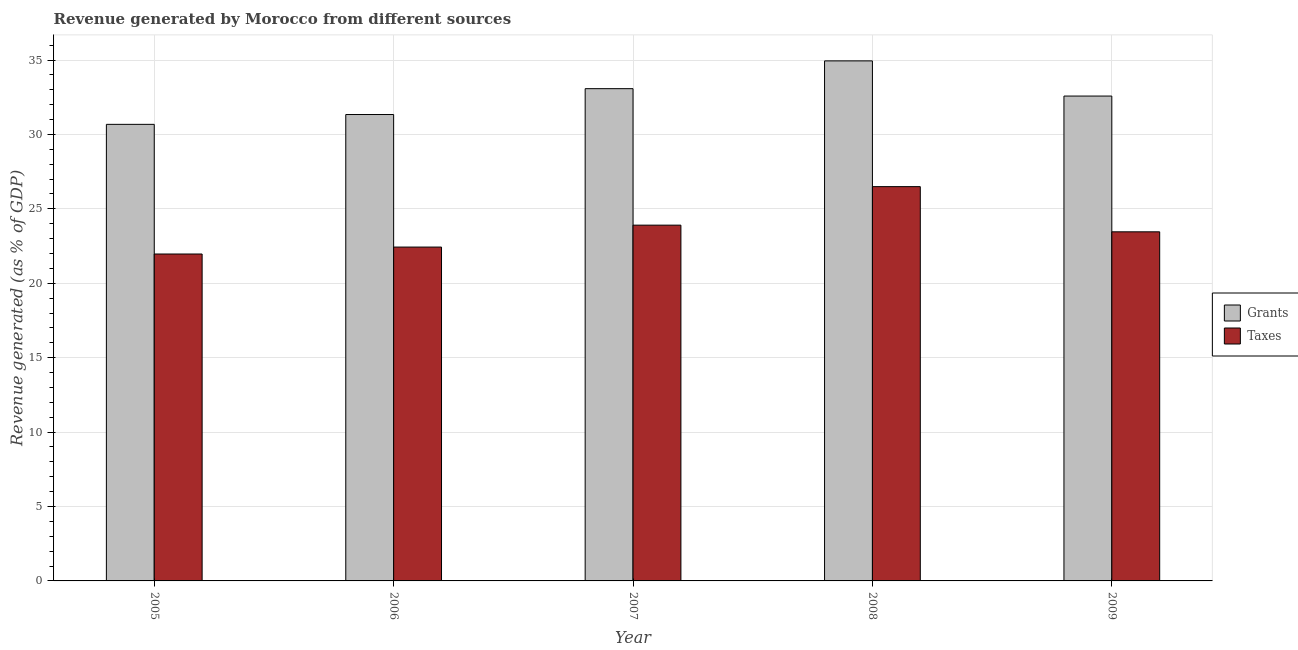How many groups of bars are there?
Keep it short and to the point. 5. Are the number of bars per tick equal to the number of legend labels?
Offer a very short reply. Yes. Are the number of bars on each tick of the X-axis equal?
Provide a succinct answer. Yes. What is the label of the 1st group of bars from the left?
Your answer should be very brief. 2005. In how many cases, is the number of bars for a given year not equal to the number of legend labels?
Offer a terse response. 0. What is the revenue generated by grants in 2006?
Keep it short and to the point. 31.34. Across all years, what is the maximum revenue generated by taxes?
Give a very brief answer. 26.49. Across all years, what is the minimum revenue generated by taxes?
Provide a short and direct response. 21.97. In which year was the revenue generated by grants minimum?
Offer a terse response. 2005. What is the total revenue generated by grants in the graph?
Ensure brevity in your answer.  162.61. What is the difference between the revenue generated by taxes in 2007 and that in 2009?
Your answer should be compact. 0.45. What is the difference between the revenue generated by grants in 2006 and the revenue generated by taxes in 2008?
Offer a very short reply. -3.6. What is the average revenue generated by grants per year?
Ensure brevity in your answer.  32.52. What is the ratio of the revenue generated by grants in 2007 to that in 2008?
Your response must be concise. 0.95. Is the revenue generated by taxes in 2007 less than that in 2009?
Keep it short and to the point. No. Is the difference between the revenue generated by taxes in 2005 and 2009 greater than the difference between the revenue generated by grants in 2005 and 2009?
Keep it short and to the point. No. What is the difference between the highest and the second highest revenue generated by taxes?
Your response must be concise. 2.59. What is the difference between the highest and the lowest revenue generated by taxes?
Ensure brevity in your answer.  4.53. What does the 2nd bar from the left in 2005 represents?
Provide a succinct answer. Taxes. What does the 1st bar from the right in 2007 represents?
Your answer should be compact. Taxes. How many bars are there?
Your answer should be very brief. 10. How many years are there in the graph?
Your answer should be very brief. 5. Are the values on the major ticks of Y-axis written in scientific E-notation?
Offer a very short reply. No. Does the graph contain any zero values?
Your response must be concise. No. Where does the legend appear in the graph?
Ensure brevity in your answer.  Center right. How many legend labels are there?
Give a very brief answer. 2. How are the legend labels stacked?
Your answer should be very brief. Vertical. What is the title of the graph?
Keep it short and to the point. Revenue generated by Morocco from different sources. What is the label or title of the Y-axis?
Offer a terse response. Revenue generated (as % of GDP). What is the Revenue generated (as % of GDP) of Grants in 2005?
Your answer should be very brief. 30.68. What is the Revenue generated (as % of GDP) in Taxes in 2005?
Your response must be concise. 21.97. What is the Revenue generated (as % of GDP) of Grants in 2006?
Your answer should be very brief. 31.34. What is the Revenue generated (as % of GDP) in Taxes in 2006?
Offer a terse response. 22.43. What is the Revenue generated (as % of GDP) in Grants in 2007?
Provide a short and direct response. 33.08. What is the Revenue generated (as % of GDP) of Taxes in 2007?
Offer a very short reply. 23.91. What is the Revenue generated (as % of GDP) of Grants in 2008?
Provide a short and direct response. 34.94. What is the Revenue generated (as % of GDP) of Taxes in 2008?
Your answer should be compact. 26.49. What is the Revenue generated (as % of GDP) in Grants in 2009?
Provide a succinct answer. 32.58. What is the Revenue generated (as % of GDP) in Taxes in 2009?
Your response must be concise. 23.46. Across all years, what is the maximum Revenue generated (as % of GDP) in Grants?
Offer a terse response. 34.94. Across all years, what is the maximum Revenue generated (as % of GDP) in Taxes?
Make the answer very short. 26.49. Across all years, what is the minimum Revenue generated (as % of GDP) of Grants?
Make the answer very short. 30.68. Across all years, what is the minimum Revenue generated (as % of GDP) of Taxes?
Offer a very short reply. 21.97. What is the total Revenue generated (as % of GDP) in Grants in the graph?
Ensure brevity in your answer.  162.61. What is the total Revenue generated (as % of GDP) of Taxes in the graph?
Your response must be concise. 118.25. What is the difference between the Revenue generated (as % of GDP) of Grants in 2005 and that in 2006?
Your response must be concise. -0.66. What is the difference between the Revenue generated (as % of GDP) in Taxes in 2005 and that in 2006?
Your response must be concise. -0.47. What is the difference between the Revenue generated (as % of GDP) in Grants in 2005 and that in 2007?
Provide a succinct answer. -2.4. What is the difference between the Revenue generated (as % of GDP) in Taxes in 2005 and that in 2007?
Keep it short and to the point. -1.94. What is the difference between the Revenue generated (as % of GDP) of Grants in 2005 and that in 2008?
Offer a very short reply. -4.26. What is the difference between the Revenue generated (as % of GDP) of Taxes in 2005 and that in 2008?
Your answer should be very brief. -4.53. What is the difference between the Revenue generated (as % of GDP) in Grants in 2005 and that in 2009?
Your response must be concise. -1.9. What is the difference between the Revenue generated (as % of GDP) of Taxes in 2005 and that in 2009?
Your answer should be compact. -1.49. What is the difference between the Revenue generated (as % of GDP) of Grants in 2006 and that in 2007?
Your answer should be very brief. -1.74. What is the difference between the Revenue generated (as % of GDP) in Taxes in 2006 and that in 2007?
Provide a succinct answer. -1.47. What is the difference between the Revenue generated (as % of GDP) of Grants in 2006 and that in 2008?
Make the answer very short. -3.6. What is the difference between the Revenue generated (as % of GDP) in Taxes in 2006 and that in 2008?
Keep it short and to the point. -4.06. What is the difference between the Revenue generated (as % of GDP) in Grants in 2006 and that in 2009?
Keep it short and to the point. -1.24. What is the difference between the Revenue generated (as % of GDP) in Taxes in 2006 and that in 2009?
Your answer should be very brief. -1.02. What is the difference between the Revenue generated (as % of GDP) in Grants in 2007 and that in 2008?
Your response must be concise. -1.87. What is the difference between the Revenue generated (as % of GDP) in Taxes in 2007 and that in 2008?
Your response must be concise. -2.59. What is the difference between the Revenue generated (as % of GDP) of Grants in 2007 and that in 2009?
Your answer should be compact. 0.5. What is the difference between the Revenue generated (as % of GDP) of Taxes in 2007 and that in 2009?
Provide a succinct answer. 0.45. What is the difference between the Revenue generated (as % of GDP) in Grants in 2008 and that in 2009?
Give a very brief answer. 2.36. What is the difference between the Revenue generated (as % of GDP) of Taxes in 2008 and that in 2009?
Provide a short and direct response. 3.04. What is the difference between the Revenue generated (as % of GDP) of Grants in 2005 and the Revenue generated (as % of GDP) of Taxes in 2006?
Provide a short and direct response. 8.25. What is the difference between the Revenue generated (as % of GDP) of Grants in 2005 and the Revenue generated (as % of GDP) of Taxes in 2007?
Your response must be concise. 6.77. What is the difference between the Revenue generated (as % of GDP) of Grants in 2005 and the Revenue generated (as % of GDP) of Taxes in 2008?
Offer a terse response. 4.19. What is the difference between the Revenue generated (as % of GDP) in Grants in 2005 and the Revenue generated (as % of GDP) in Taxes in 2009?
Offer a terse response. 7.22. What is the difference between the Revenue generated (as % of GDP) of Grants in 2006 and the Revenue generated (as % of GDP) of Taxes in 2007?
Provide a short and direct response. 7.43. What is the difference between the Revenue generated (as % of GDP) of Grants in 2006 and the Revenue generated (as % of GDP) of Taxes in 2008?
Offer a very short reply. 4.85. What is the difference between the Revenue generated (as % of GDP) of Grants in 2006 and the Revenue generated (as % of GDP) of Taxes in 2009?
Give a very brief answer. 7.88. What is the difference between the Revenue generated (as % of GDP) in Grants in 2007 and the Revenue generated (as % of GDP) in Taxes in 2008?
Make the answer very short. 6.58. What is the difference between the Revenue generated (as % of GDP) of Grants in 2007 and the Revenue generated (as % of GDP) of Taxes in 2009?
Give a very brief answer. 9.62. What is the difference between the Revenue generated (as % of GDP) of Grants in 2008 and the Revenue generated (as % of GDP) of Taxes in 2009?
Your response must be concise. 11.49. What is the average Revenue generated (as % of GDP) of Grants per year?
Your answer should be compact. 32.52. What is the average Revenue generated (as % of GDP) of Taxes per year?
Offer a terse response. 23.65. In the year 2005, what is the difference between the Revenue generated (as % of GDP) in Grants and Revenue generated (as % of GDP) in Taxes?
Your answer should be very brief. 8.71. In the year 2006, what is the difference between the Revenue generated (as % of GDP) in Grants and Revenue generated (as % of GDP) in Taxes?
Offer a very short reply. 8.91. In the year 2007, what is the difference between the Revenue generated (as % of GDP) in Grants and Revenue generated (as % of GDP) in Taxes?
Your answer should be very brief. 9.17. In the year 2008, what is the difference between the Revenue generated (as % of GDP) of Grants and Revenue generated (as % of GDP) of Taxes?
Your answer should be compact. 8.45. In the year 2009, what is the difference between the Revenue generated (as % of GDP) in Grants and Revenue generated (as % of GDP) in Taxes?
Your response must be concise. 9.12. What is the ratio of the Revenue generated (as % of GDP) in Grants in 2005 to that in 2006?
Your response must be concise. 0.98. What is the ratio of the Revenue generated (as % of GDP) of Taxes in 2005 to that in 2006?
Give a very brief answer. 0.98. What is the ratio of the Revenue generated (as % of GDP) of Grants in 2005 to that in 2007?
Keep it short and to the point. 0.93. What is the ratio of the Revenue generated (as % of GDP) of Taxes in 2005 to that in 2007?
Provide a succinct answer. 0.92. What is the ratio of the Revenue generated (as % of GDP) of Grants in 2005 to that in 2008?
Provide a succinct answer. 0.88. What is the ratio of the Revenue generated (as % of GDP) of Taxes in 2005 to that in 2008?
Your answer should be compact. 0.83. What is the ratio of the Revenue generated (as % of GDP) of Grants in 2005 to that in 2009?
Provide a succinct answer. 0.94. What is the ratio of the Revenue generated (as % of GDP) of Taxes in 2005 to that in 2009?
Offer a very short reply. 0.94. What is the ratio of the Revenue generated (as % of GDP) in Grants in 2006 to that in 2007?
Your response must be concise. 0.95. What is the ratio of the Revenue generated (as % of GDP) of Taxes in 2006 to that in 2007?
Provide a succinct answer. 0.94. What is the ratio of the Revenue generated (as % of GDP) in Grants in 2006 to that in 2008?
Give a very brief answer. 0.9. What is the ratio of the Revenue generated (as % of GDP) of Taxes in 2006 to that in 2008?
Your answer should be very brief. 0.85. What is the ratio of the Revenue generated (as % of GDP) in Grants in 2006 to that in 2009?
Offer a terse response. 0.96. What is the ratio of the Revenue generated (as % of GDP) of Taxes in 2006 to that in 2009?
Your answer should be very brief. 0.96. What is the ratio of the Revenue generated (as % of GDP) in Grants in 2007 to that in 2008?
Give a very brief answer. 0.95. What is the ratio of the Revenue generated (as % of GDP) in Taxes in 2007 to that in 2008?
Give a very brief answer. 0.9. What is the ratio of the Revenue generated (as % of GDP) of Grants in 2007 to that in 2009?
Your answer should be very brief. 1.02. What is the ratio of the Revenue generated (as % of GDP) of Taxes in 2007 to that in 2009?
Make the answer very short. 1.02. What is the ratio of the Revenue generated (as % of GDP) in Grants in 2008 to that in 2009?
Keep it short and to the point. 1.07. What is the ratio of the Revenue generated (as % of GDP) in Taxes in 2008 to that in 2009?
Keep it short and to the point. 1.13. What is the difference between the highest and the second highest Revenue generated (as % of GDP) of Grants?
Your answer should be compact. 1.87. What is the difference between the highest and the second highest Revenue generated (as % of GDP) of Taxes?
Provide a succinct answer. 2.59. What is the difference between the highest and the lowest Revenue generated (as % of GDP) of Grants?
Offer a terse response. 4.26. What is the difference between the highest and the lowest Revenue generated (as % of GDP) in Taxes?
Your response must be concise. 4.53. 